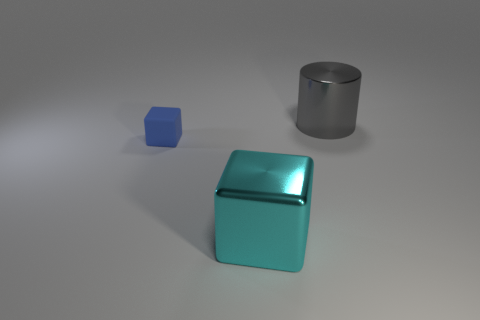Add 3 tiny brown metallic spheres. How many objects exist? 6 Subtract all blocks. How many objects are left? 1 Subtract all red objects. Subtract all large blocks. How many objects are left? 2 Add 3 small objects. How many small objects are left? 4 Add 1 cyan metal objects. How many cyan metal objects exist? 2 Subtract 0 yellow cubes. How many objects are left? 3 Subtract all brown cubes. Subtract all blue cylinders. How many cubes are left? 2 